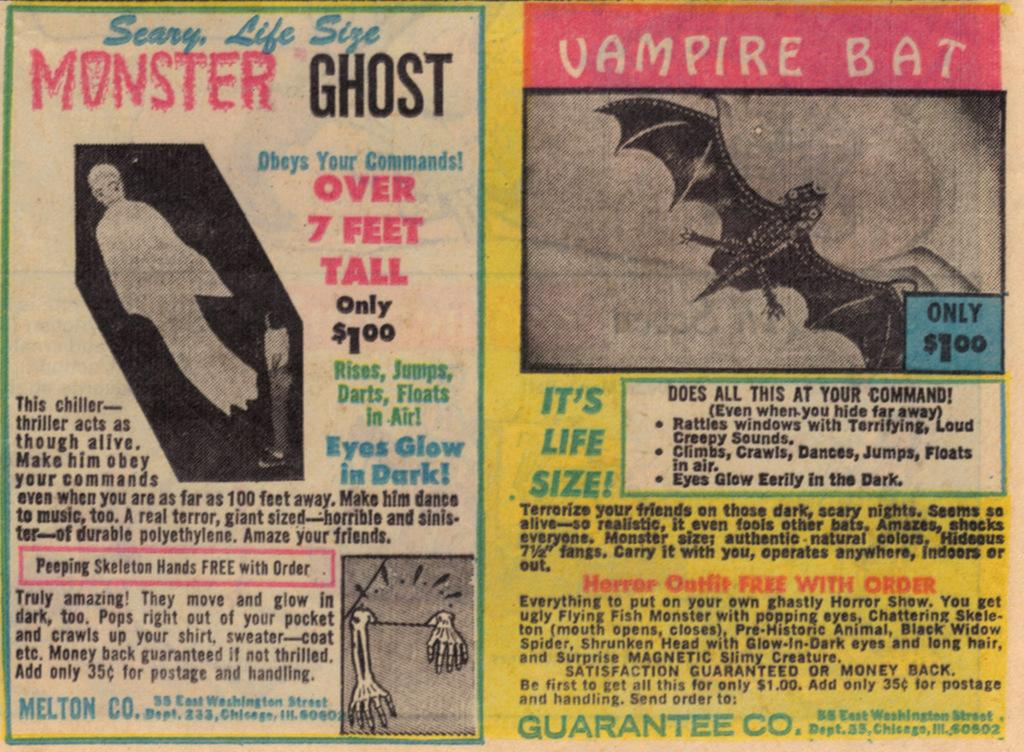Provide a one-sentence caption for the provided image. An old newspaper clipping of advertisements for a Scary, Life Size Monster Ghost and a Vampire Bat. 